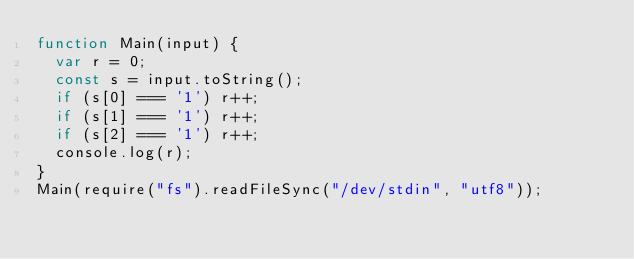Convert code to text. <code><loc_0><loc_0><loc_500><loc_500><_JavaScript_>function Main(input) {
  var r = 0;
  const s = input.toString();
  if (s[0] === '1') r++;
  if (s[1] === '1') r++;
  if (s[2] === '1') r++;
  console.log(r);
}
Main(require("fs").readFileSync("/dev/stdin", "utf8"));</code> 